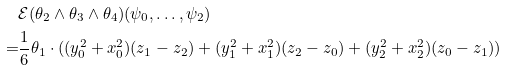Convert formula to latex. <formula><loc_0><loc_0><loc_500><loc_500>& \mathcal { E } ( \theta _ { 2 } \wedge \theta _ { 3 } \wedge \theta _ { 4 } ) ( \psi _ { 0 } , \dots , \psi _ { 2 } ) \\ = & \frac { 1 } { 6 } \theta _ { 1 } \cdot ( ( y _ { 0 } ^ { 2 } + x _ { 0 } ^ { 2 } ) ( z _ { 1 } - z _ { 2 } ) + ( y _ { 1 } ^ { 2 } + x _ { 1 } ^ { 2 } ) ( z _ { 2 } - z _ { 0 } ) + ( y _ { 2 } ^ { 2 } + x _ { 2 } ^ { 2 } ) ( z _ { 0 } - z _ { 1 } ) )</formula> 